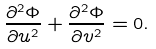<formula> <loc_0><loc_0><loc_500><loc_500>\frac { \partial ^ { 2 } \Phi } { \partial u ^ { 2 } } + \frac { \partial ^ { 2 } \Phi } { \partial v ^ { 2 } } = 0 .</formula> 